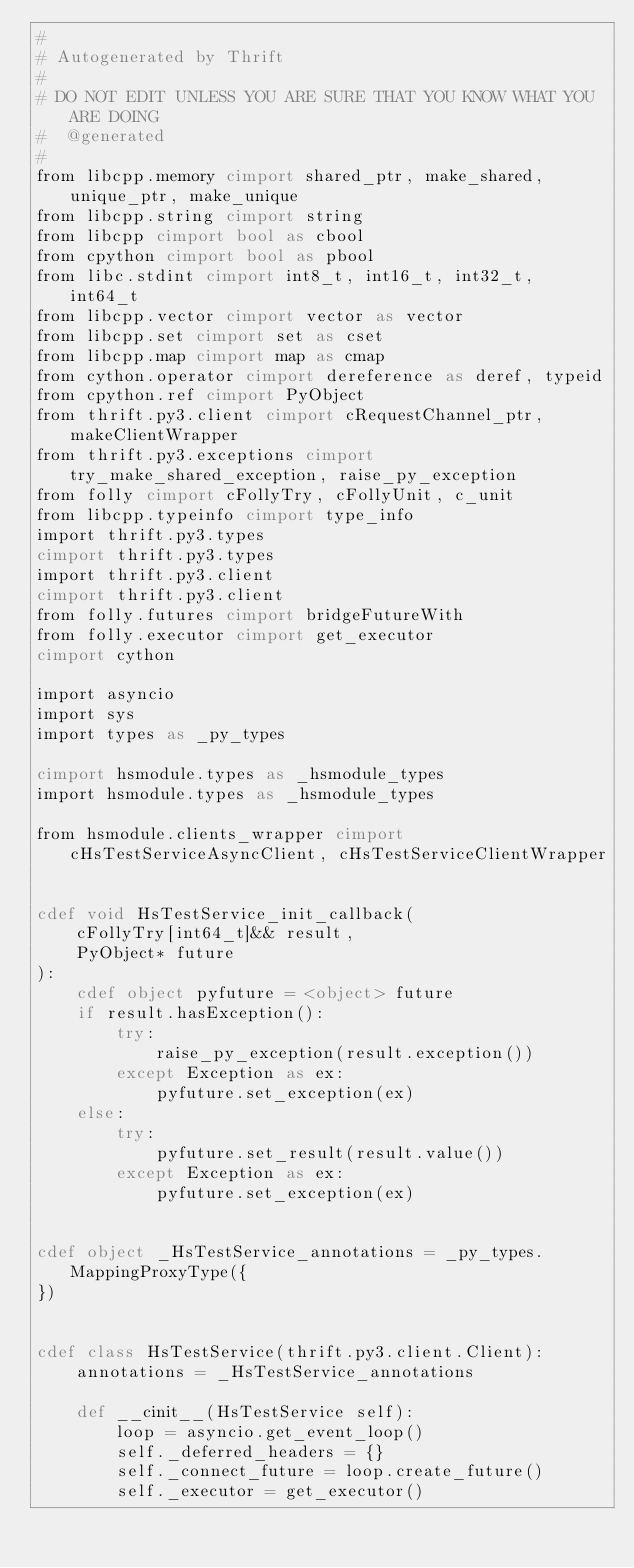<code> <loc_0><loc_0><loc_500><loc_500><_Cython_>#
# Autogenerated by Thrift
#
# DO NOT EDIT UNLESS YOU ARE SURE THAT YOU KNOW WHAT YOU ARE DOING
#  @generated
#
from libcpp.memory cimport shared_ptr, make_shared, unique_ptr, make_unique
from libcpp.string cimport string
from libcpp cimport bool as cbool
from cpython cimport bool as pbool
from libc.stdint cimport int8_t, int16_t, int32_t, int64_t
from libcpp.vector cimport vector as vector
from libcpp.set cimport set as cset
from libcpp.map cimport map as cmap
from cython.operator cimport dereference as deref, typeid
from cpython.ref cimport PyObject
from thrift.py3.client cimport cRequestChannel_ptr, makeClientWrapper
from thrift.py3.exceptions cimport try_make_shared_exception, raise_py_exception
from folly cimport cFollyTry, cFollyUnit, c_unit
from libcpp.typeinfo cimport type_info
import thrift.py3.types
cimport thrift.py3.types
import thrift.py3.client
cimport thrift.py3.client
from folly.futures cimport bridgeFutureWith
from folly.executor cimport get_executor
cimport cython

import asyncio
import sys
import types as _py_types

cimport hsmodule.types as _hsmodule_types
import hsmodule.types as _hsmodule_types

from hsmodule.clients_wrapper cimport cHsTestServiceAsyncClient, cHsTestServiceClientWrapper


cdef void HsTestService_init_callback(
    cFollyTry[int64_t]&& result,
    PyObject* future
):
    cdef object pyfuture = <object> future
    if result.hasException():
        try:
            raise_py_exception(result.exception())
        except Exception as ex:
            pyfuture.set_exception(ex)
    else:
        try:
            pyfuture.set_result(result.value())
        except Exception as ex:
            pyfuture.set_exception(ex)


cdef object _HsTestService_annotations = _py_types.MappingProxyType({
})


cdef class HsTestService(thrift.py3.client.Client):
    annotations = _HsTestService_annotations

    def __cinit__(HsTestService self):
        loop = asyncio.get_event_loop()
        self._deferred_headers = {}
        self._connect_future = loop.create_future()
        self._executor = get_executor()
</code> 